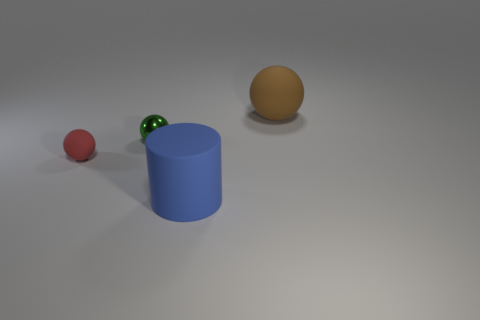Subtract all tiny red spheres. How many spheres are left? 2 Add 3 tiny red rubber spheres. How many objects exist? 7 Subtract all brown balls. How many balls are left? 2 Subtract all balls. How many objects are left? 1 Subtract 0 green cubes. How many objects are left? 4 Subtract 3 balls. How many balls are left? 0 Subtract all red balls. Subtract all brown cylinders. How many balls are left? 2 Subtract all large things. Subtract all metallic objects. How many objects are left? 1 Add 3 tiny green balls. How many tiny green balls are left? 4 Add 1 large brown objects. How many large brown objects exist? 2 